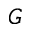<formula> <loc_0><loc_0><loc_500><loc_500>G</formula> 